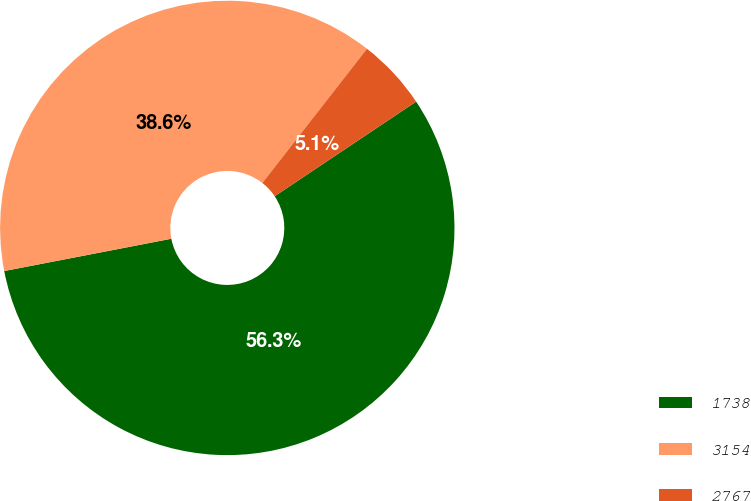<chart> <loc_0><loc_0><loc_500><loc_500><pie_chart><fcel>1738<fcel>3154<fcel>2767<nl><fcel>56.35%<fcel>38.58%<fcel>5.08%<nl></chart> 